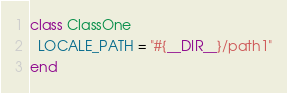<code> <loc_0><loc_0><loc_500><loc_500><_Crystal_>class ClassOne
  LOCALE_PATH = "#{__DIR__}/path1"
end
</code> 